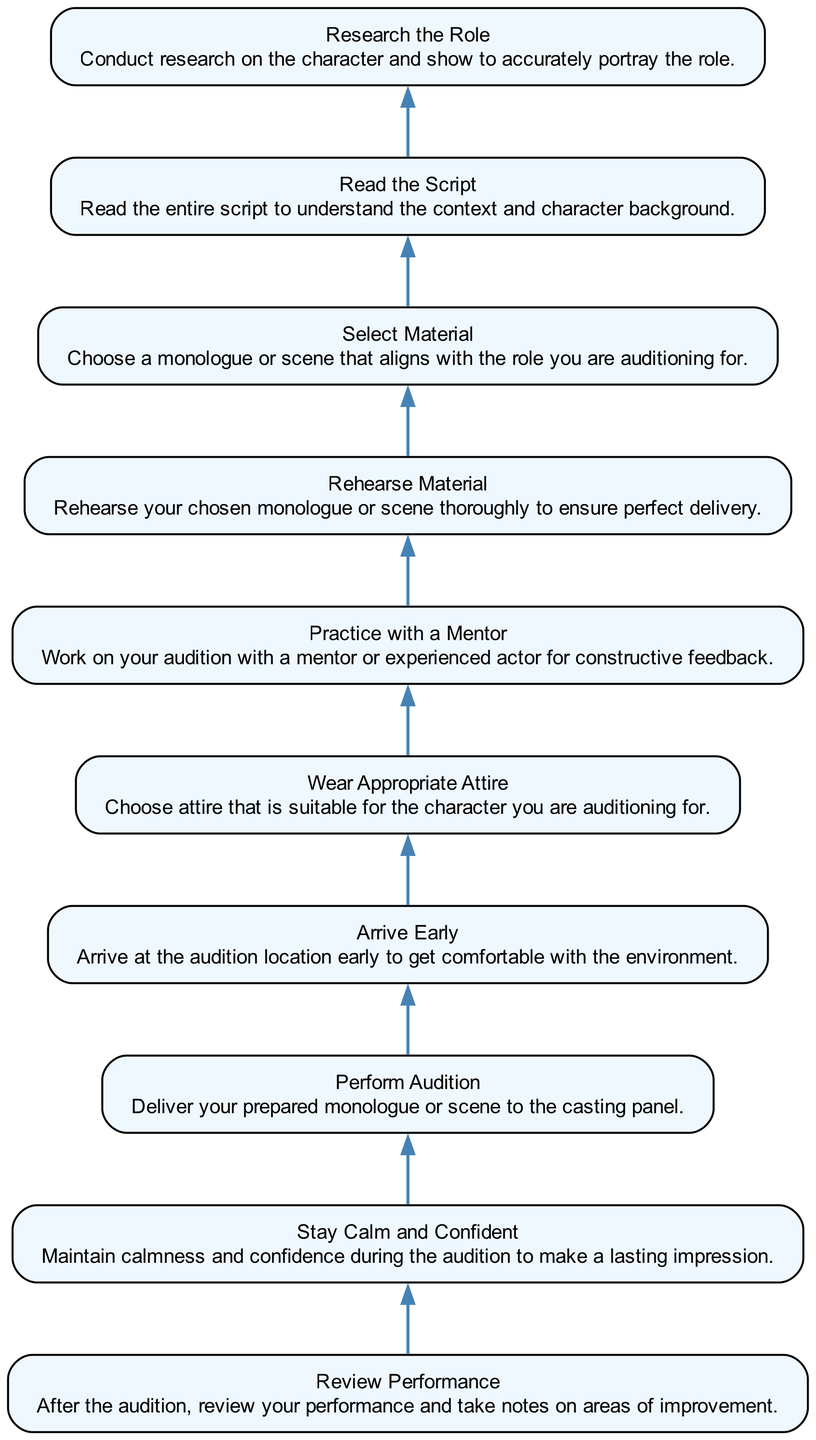What's the first step in the audition preparation flow? The diagram shows that the first step at the bottom is "Research the Role." This is the initial action before moving up the flow chart.
Answer: Research the Role How many steps are included in the audition preparation flow? By counting the nodes in the diagram, there are a total of 10 steps represented. This gives an overview of the entire preparation process.
Answer: 10 What is the final step of the audition preparation? The highest step in the flow chart is "Review Performance," which indicates that this step comes last after all others have been completed.
Answer: Review Performance Which step comes immediately before performing the audition? The step "Rehearse Material" is directly above "Perform Audition" in the diagram, indicating that it precedes the actual audition performance.
Answer: Rehearse Material Is "Stay Calm and Confident" a preliminary or later step in the process? This step can be found near the end of the flow chart, just before "Perform Audition," indicating its function in preparing for the actual audition, and categorizing it as a later step.
Answer: Later step What is the relationship between "Select Material" and "Read the Script"? In the diagram, "Select Material" appears directly below "Read the Script," indicating that selecting the audition material relies on understanding the script first.
Answer: "Select Material" is below "Read the Script" What action should be taken right after choosing your audition material? According to the order in the flow chart, immediately after "Select Material," the next step is "Rehearse Material," suggesting that rehearsal follows the selection.
Answer: Rehearse Material Which step emphasizes the importance of appropriate attire? The step labeled "Wear Appropriate Attire" highlights the need for proper clothing choices and its connection to the character during auditions, coming after arriving early.
Answer: Wear Appropriate Attire What is the significance of practicing with a mentor in this flow? The step "Practice with a Mentor" appears early in the preparation process, suggesting that seeking guidance is crucial for constructive feedback and improving performance before the audition.
Answer: Important for feedback 